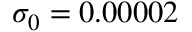Convert formula to latex. <formula><loc_0><loc_0><loc_500><loc_500>\sigma _ { 0 } = 0 . 0 0 0 0 2</formula> 